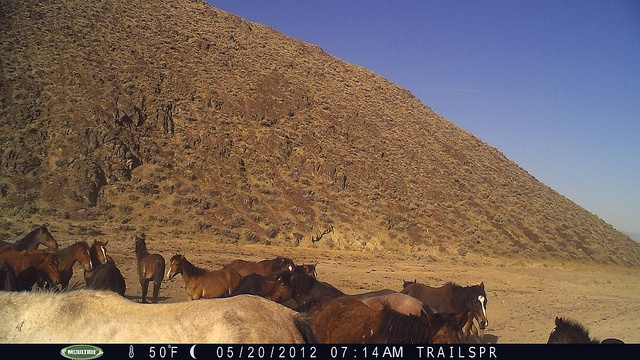Describe the objects in this image and their specific colors. I can see horse in black and tan tones, horse in black, maroon, and brown tones, horse in black, maroon, and gray tones, horse in black, maroon, and brown tones, and horse in black, maroon, and tan tones in this image. 